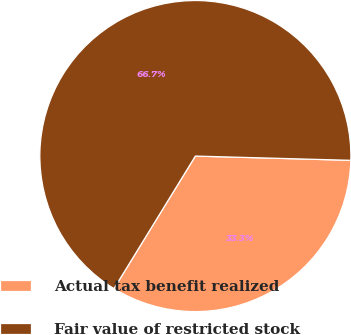Convert chart. <chart><loc_0><loc_0><loc_500><loc_500><pie_chart><fcel>Actual tax benefit realized<fcel>Fair value of restricted stock<nl><fcel>33.33%<fcel>66.67%<nl></chart> 